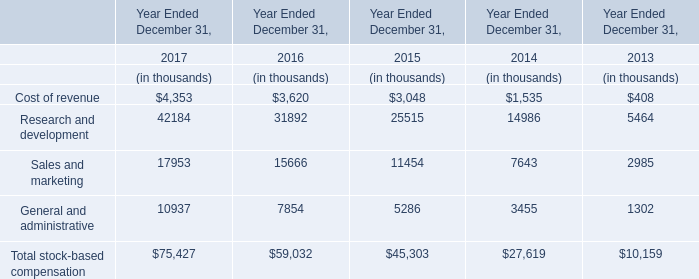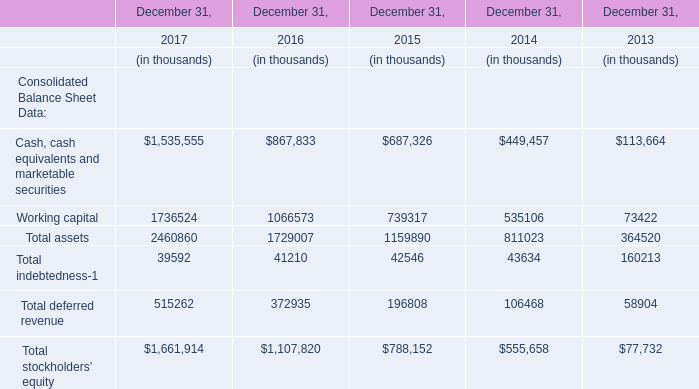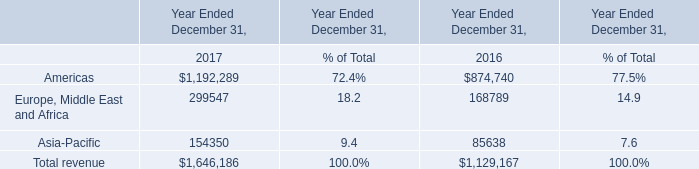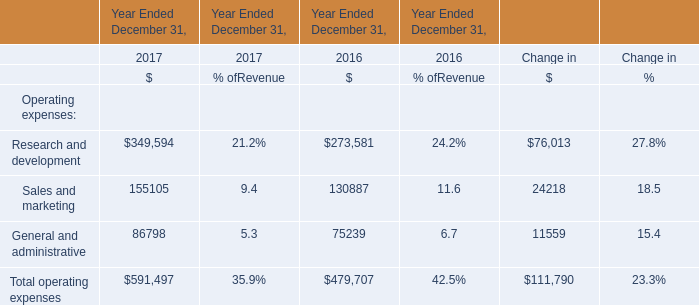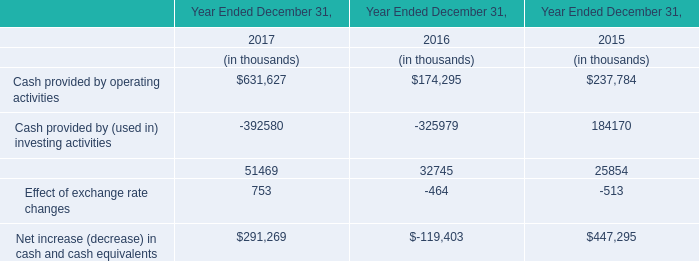What will Total stockholders' equity reach in 2018 if it continues to grow at its current rate? (in thousand) 
Computations: (1661914 + ((1661914 * (1661914 - 1107820)) / 1107820))
Answer: 2493147.03056. 